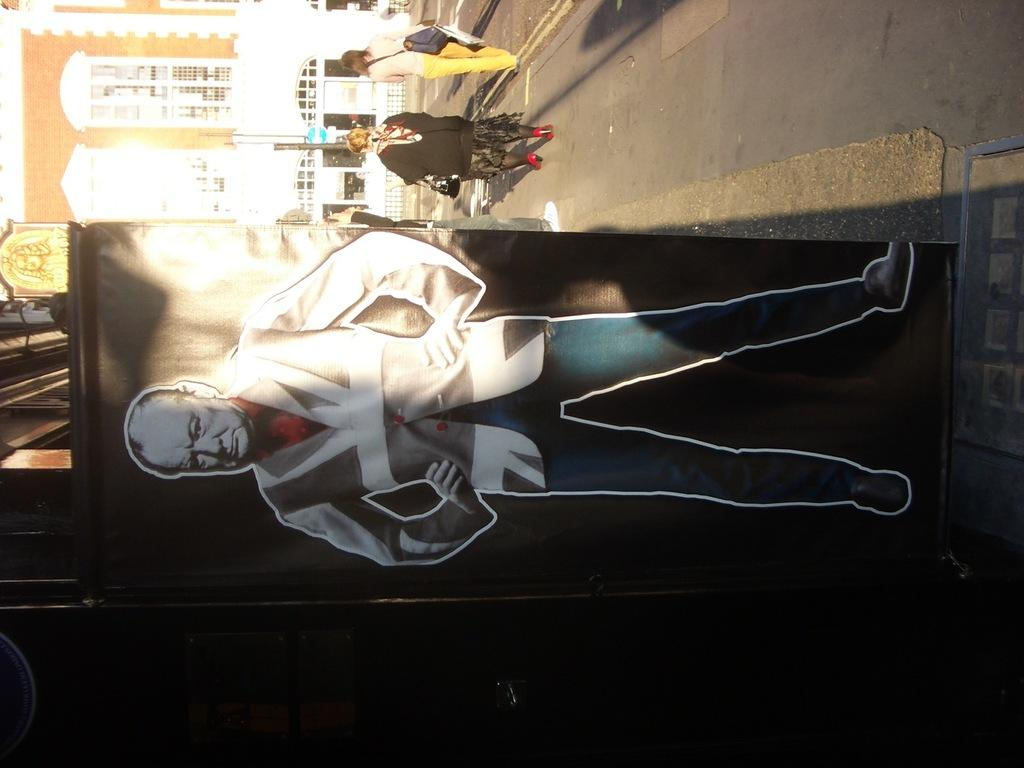What is depicted on the board in the image? There is a board with an image of a person in the image. What can be seen in the background of the image? There is a road and buildings in the image. What are the people on the road doing? The people on the road are carrying bags. What type of beef is being transported in the crate on the road? There is no crate or beef present in the image. What color is the tongue of the person depicted on the board? The image of the person on the board does not show their tongue, so we cannot determine its color. 